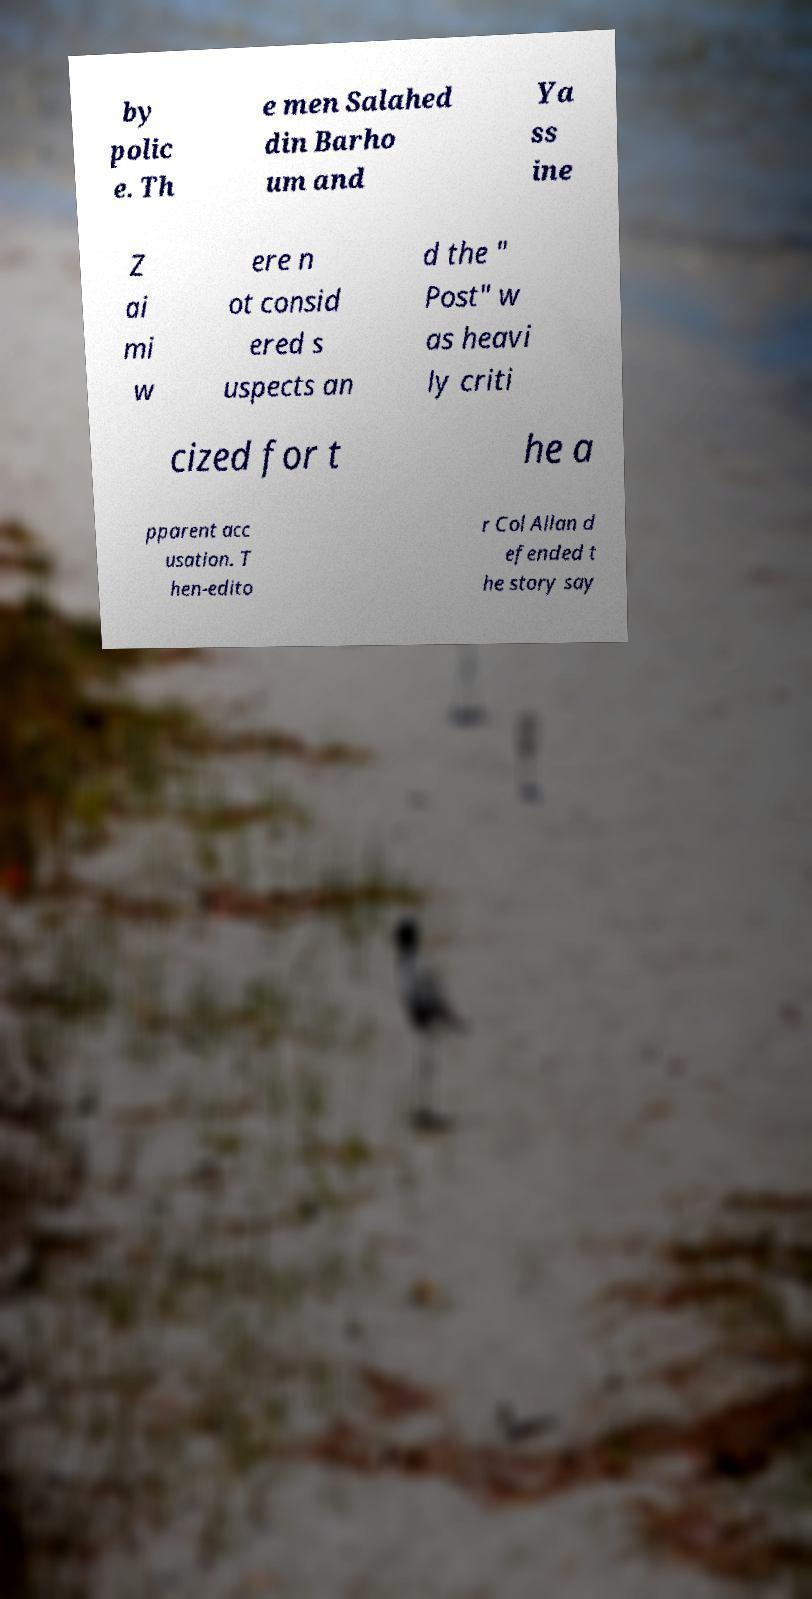Please identify and transcribe the text found in this image. by polic e. Th e men Salahed din Barho um and Ya ss ine Z ai mi w ere n ot consid ered s uspects an d the " Post" w as heavi ly criti cized for t he a pparent acc usation. T hen-edito r Col Allan d efended t he story say 